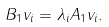<formula> <loc_0><loc_0><loc_500><loc_500>B _ { 1 } v _ { i } = \lambda _ { i } A _ { 1 } v _ { i } .</formula> 